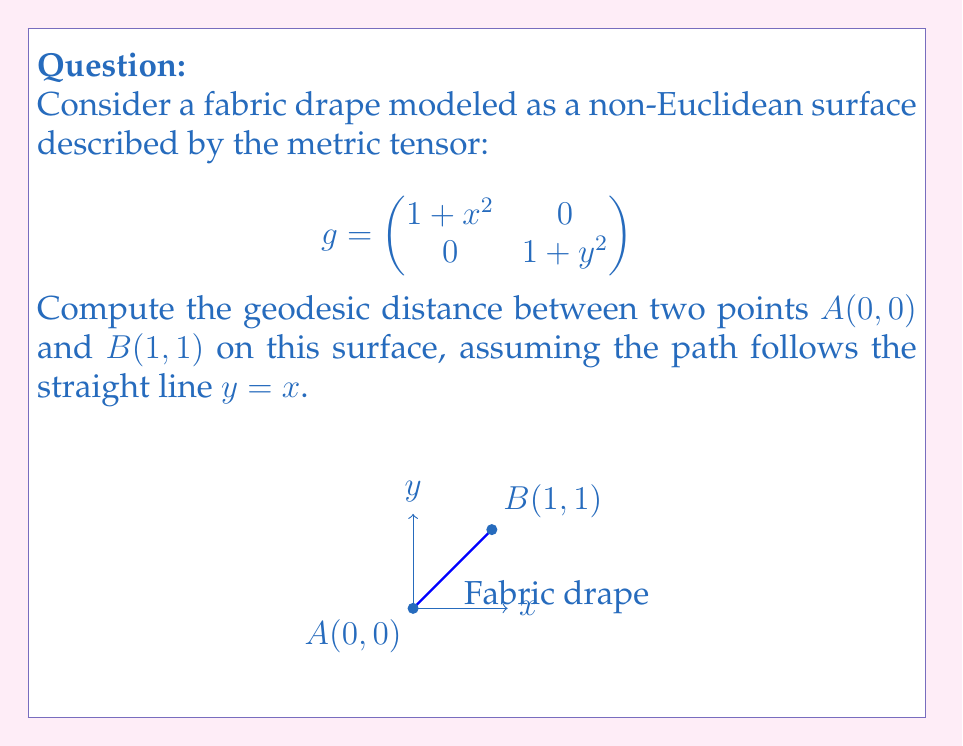Give your solution to this math problem. To compute the geodesic distance, we need to follow these steps:

1) The geodesic distance is given by the line integral:

   $$L = \int_0^1 \sqrt{g_{ij} \frac{dx^i}{dt} \frac{dx^j}{dt}} dt$$

2) For the straight line $y=x$, we have $\frac{dx}{dt} = \frac{dy}{dt} = 1$

3) Substituting into the metric tensor:

   $$L = \int_0^1 \sqrt{(1+t^2) \cdot 1^2 + (1+t^2) \cdot 1^2} dt$$

4) Simplifying:

   $$L = \int_0^1 \sqrt{2(1+t^2)} dt = \sqrt{2} \int_0^1 \sqrt{1+t^2} dt$$

5) This integral can be solved using the substitution $t = \tan \theta$:

   $$L = \sqrt{2} [\theta + \frac{\sin \theta \cos \theta}{2}]_0^{\pi/4}$$

6) Evaluating the limits:

   $$L = \sqrt{2} [(\frac{\pi}{4} + \frac{1}{2}) - 0] = \frac{\sqrt{2}}{4}(\pi + 2)$$
Answer: $\frac{\sqrt{2}}{4}(\pi + 2)$ 